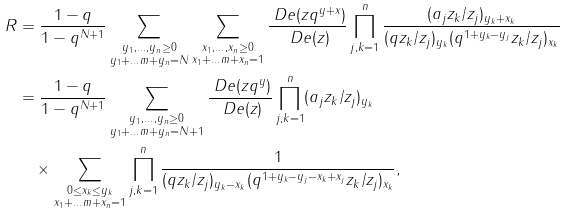Convert formula to latex. <formula><loc_0><loc_0><loc_500><loc_500>R & = \frac { 1 - q } { 1 - q ^ { N + 1 } } \sum _ { \substack { y _ { 1 } , \dots , y _ { n } \geq 0 \\ y _ { 1 } + \dots m + y _ { n } = N } } \sum _ { \substack { x _ { 1 } , \dots , x _ { n } \geq 0 \\ x _ { 1 } + \dots m + x _ { n } = 1 } } \frac { \ D e ( z q ^ { y + x } ) } { \ D e ( z ) } \prod _ { j , k = 1 } ^ { n } \frac { ( a _ { j } z _ { k } / z _ { j } ) _ { y _ { k } + x _ { k } } } { ( q z _ { k } / z _ { j } ) _ { y _ { k } } ( q ^ { 1 + y _ { k } - y _ { j } } z _ { k } / z _ { j } ) _ { x _ { k } } } \\ & = \frac { 1 - q } { 1 - q ^ { N + 1 } } \sum _ { \substack { y _ { 1 } , \dots , y _ { n } \geq 0 \\ y _ { 1 } + \dots m + y _ { n } = N + 1 } } \frac { \ D e ( z q ^ { y } ) } { \ D e ( z ) } \prod _ { j , k = 1 } ^ { n } ( a _ { j } z _ { k } / z _ { j } ) _ { y _ { k } } \\ & \quad \times \sum _ { \substack { 0 \leq x _ { k } \leq y _ { k } \\ x _ { 1 } + \dots m + x _ { n } = 1 } } \prod _ { j , k = 1 } ^ { n } \frac { 1 } { ( q z _ { k } / z _ { j } ) _ { y _ { k } - x _ { k } } ( q ^ { 1 + y _ { k } - y _ { j } - x _ { k } + x _ { j } } z _ { k } / z _ { j } ) _ { x _ { k } } } ,</formula> 